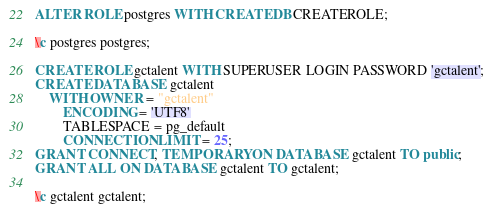Convert code to text. <code><loc_0><loc_0><loc_500><loc_500><_SQL_>ALTER ROLE postgres WITH CREATEDB CREATEROLE;

\c postgres postgres;

CREATE ROLE gctalent WITH SUPERUSER LOGIN PASSWORD 'gctalent';
CREATE DATABASE gctalent
    WITH OWNER = "gctalent"
        ENCODING = 'UTF8'
        TABLESPACE = pg_default
        CONNECTION LIMIT = 25;
GRANT CONNECT, TEMPORARY ON DATABASE gctalent TO public;
GRANT ALL ON DATABASE gctalent TO gctalent;

\c gctalent gctalent;
</code> 